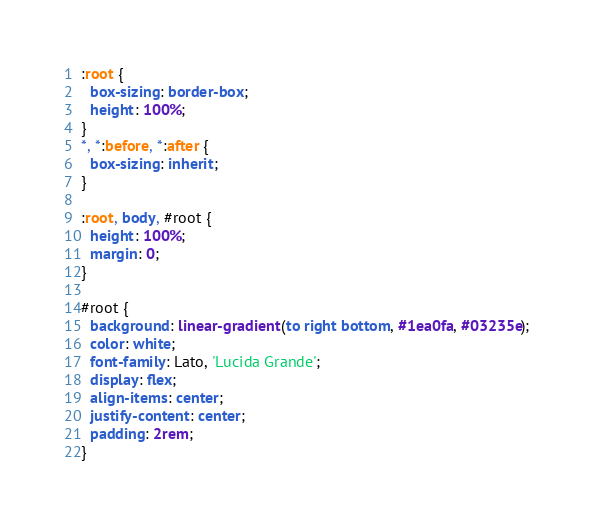<code> <loc_0><loc_0><loc_500><loc_500><_CSS_>:root {
  box-sizing: border-box;
  height: 100%;
}
*, *:before, *:after {
  box-sizing: inherit;
}

:root, body, #root {
  height: 100%;
  margin: 0;
}

#root {
  background: linear-gradient(to right bottom, #1ea0fa, #03235e);
  color: white;
  font-family: Lato, 'Lucida Grande';
  display: flex;
  align-items: center;
  justify-content: center;
  padding: 2rem;
}
</code> 